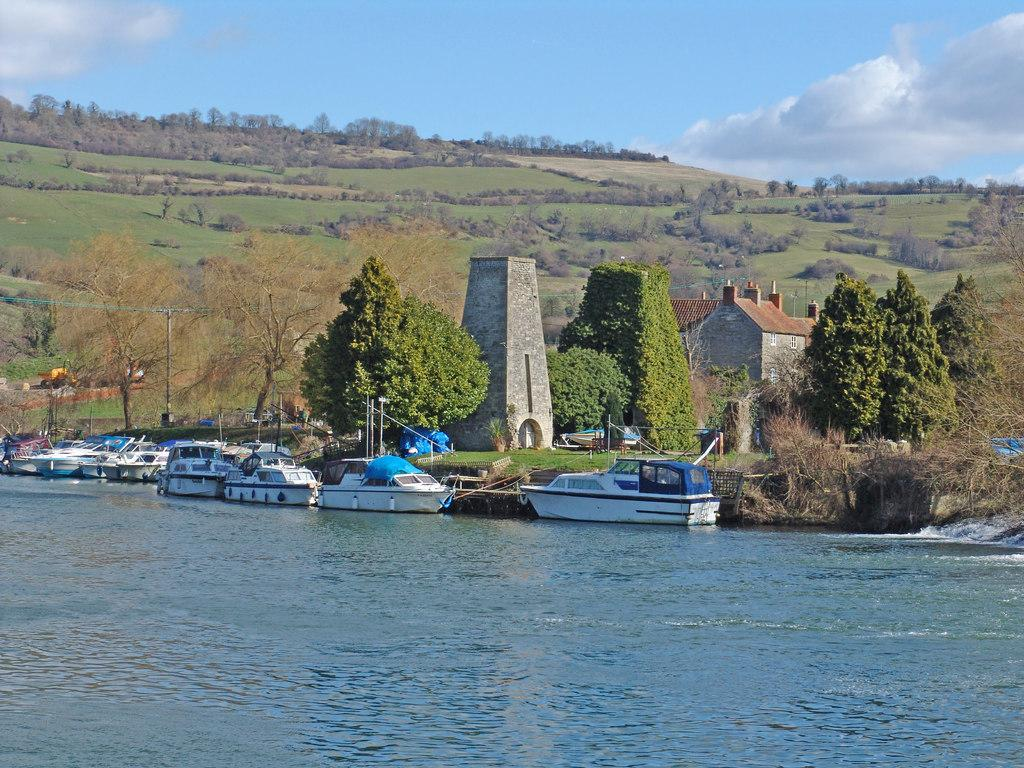What is the primary element in the image? There is water in the image. What is floating on the water? There are boats in the water. What can be seen in the background of the image? There are trees, a building, a tower, the sky, a pool, and grass visible in the background of the image. What is the condition of the sky in the image? The sky is visible in the background of the image, and there are clouds visible. What type of vegetable is being harvested by the laborer in the image? There is no laborer or vegetable present in the image. What is the source of power for the engine in the image? There is no engine present in the image. 